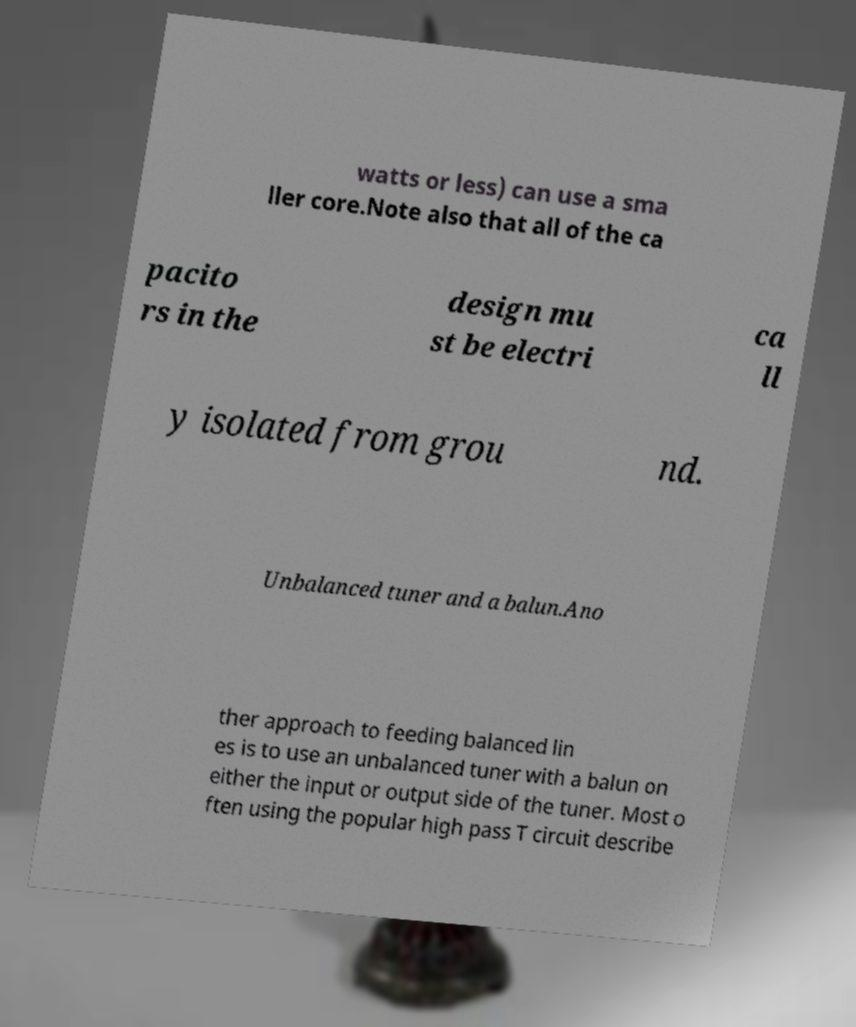Could you extract and type out the text from this image? watts or less) can use a sma ller core.Note also that all of the ca pacito rs in the design mu st be electri ca ll y isolated from grou nd. Unbalanced tuner and a balun.Ano ther approach to feeding balanced lin es is to use an unbalanced tuner with a balun on either the input or output side of the tuner. Most o ften using the popular high pass T circuit describe 